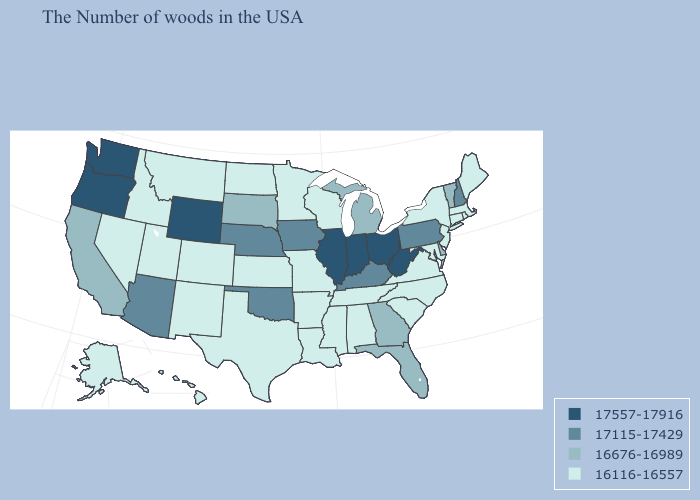Does New Hampshire have the highest value in the Northeast?
Give a very brief answer. Yes. Does Hawaii have the highest value in the West?
Write a very short answer. No. Which states have the lowest value in the Northeast?
Concise answer only. Maine, Massachusetts, Rhode Island, Connecticut, New York, New Jersey. Name the states that have a value in the range 17115-17429?
Quick response, please. New Hampshire, Pennsylvania, Kentucky, Iowa, Nebraska, Oklahoma, Arizona. Among the states that border Massachusetts , which have the lowest value?
Give a very brief answer. Rhode Island, Connecticut, New York. Is the legend a continuous bar?
Keep it brief. No. Name the states that have a value in the range 17557-17916?
Quick response, please. West Virginia, Ohio, Indiana, Illinois, Wyoming, Washington, Oregon. How many symbols are there in the legend?
Quick response, please. 4. Among the states that border Montana , does Wyoming have the lowest value?
Be succinct. No. Does the map have missing data?
Be succinct. No. Which states hav the highest value in the Northeast?
Concise answer only. New Hampshire, Pennsylvania. What is the highest value in states that border Kansas?
Keep it brief. 17115-17429. Name the states that have a value in the range 16676-16989?
Answer briefly. Vermont, Delaware, Florida, Georgia, Michigan, South Dakota, California. What is the value of Nevada?
Quick response, please. 16116-16557. What is the highest value in the USA?
Short answer required. 17557-17916. 